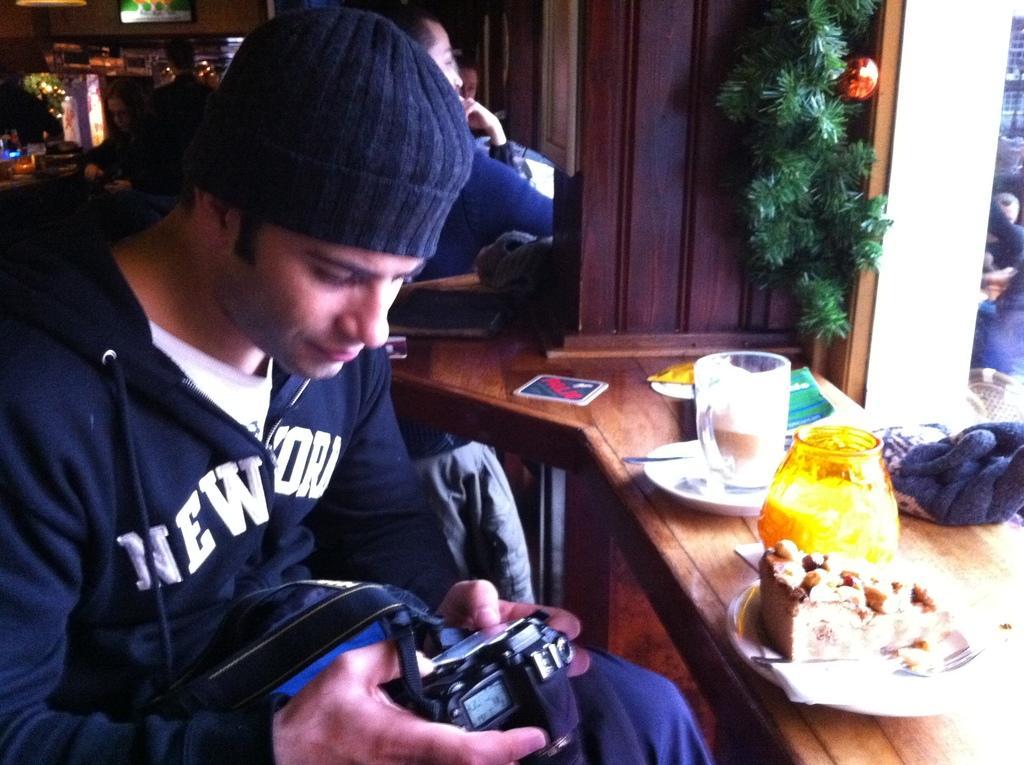Please provide a concise description of this image. In this picture we can see a man sitting on the chair near the desk, a man is holding a camera, on the desk we can see a plate of cake, glass, jar and some books. IN the background we can find a wall with some decorative plant. 